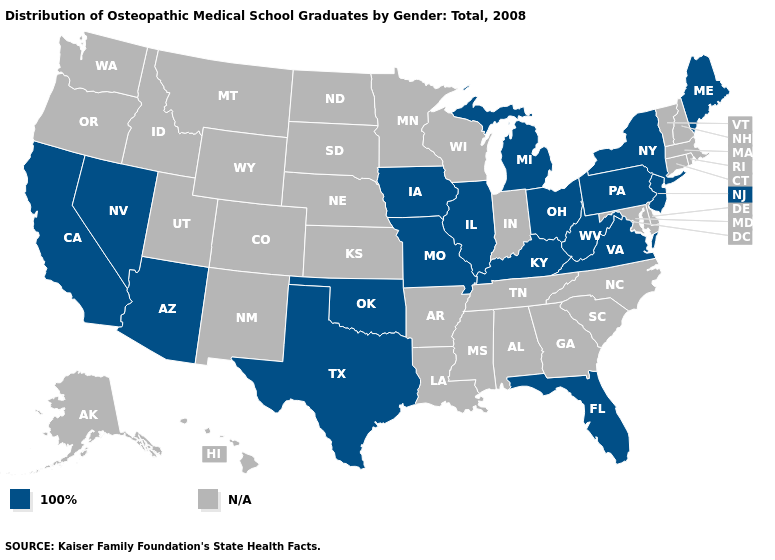Name the states that have a value in the range 100%?
Keep it brief. Arizona, California, Florida, Illinois, Iowa, Kentucky, Maine, Michigan, Missouri, Nevada, New Jersey, New York, Ohio, Oklahoma, Pennsylvania, Texas, Virginia, West Virginia. What is the value of Rhode Island?
Short answer required. N/A. How many symbols are there in the legend?
Concise answer only. 2. Which states have the lowest value in the MidWest?
Quick response, please. Illinois, Iowa, Michigan, Missouri, Ohio. What is the highest value in the West ?
Give a very brief answer. 100%. What is the lowest value in the USA?
Concise answer only. 100%. Which states hav the highest value in the MidWest?
Be succinct. Illinois, Iowa, Michigan, Missouri, Ohio. Name the states that have a value in the range N/A?
Give a very brief answer. Alabama, Alaska, Arkansas, Colorado, Connecticut, Delaware, Georgia, Hawaii, Idaho, Indiana, Kansas, Louisiana, Maryland, Massachusetts, Minnesota, Mississippi, Montana, Nebraska, New Hampshire, New Mexico, North Carolina, North Dakota, Oregon, Rhode Island, South Carolina, South Dakota, Tennessee, Utah, Vermont, Washington, Wisconsin, Wyoming. Name the states that have a value in the range 100%?
Be succinct. Arizona, California, Florida, Illinois, Iowa, Kentucky, Maine, Michigan, Missouri, Nevada, New Jersey, New York, Ohio, Oklahoma, Pennsylvania, Texas, Virginia, West Virginia. Does the first symbol in the legend represent the smallest category?
Write a very short answer. Yes. 